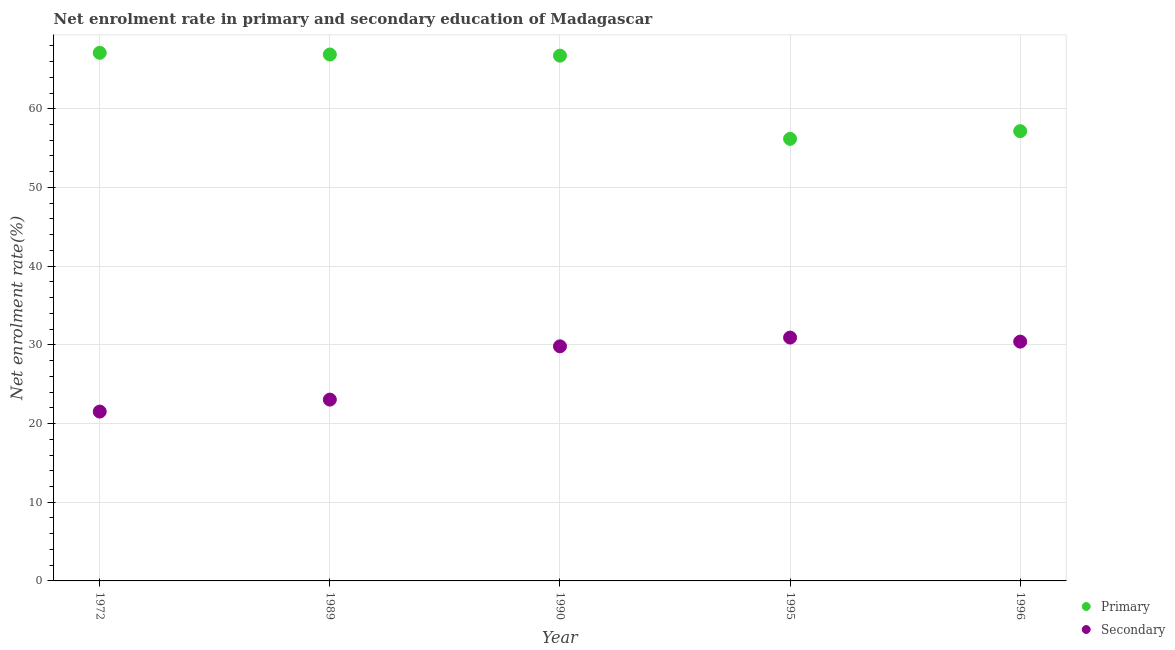What is the enrollment rate in primary education in 1989?
Your answer should be very brief. 66.9. Across all years, what is the maximum enrollment rate in secondary education?
Keep it short and to the point. 30.93. Across all years, what is the minimum enrollment rate in secondary education?
Ensure brevity in your answer.  21.52. In which year was the enrollment rate in secondary education maximum?
Your response must be concise. 1995. In which year was the enrollment rate in secondary education minimum?
Provide a succinct answer. 1972. What is the total enrollment rate in secondary education in the graph?
Keep it short and to the point. 135.71. What is the difference between the enrollment rate in secondary education in 1972 and that in 1996?
Provide a succinct answer. -8.89. What is the difference between the enrollment rate in primary education in 1989 and the enrollment rate in secondary education in 1996?
Provide a short and direct response. 36.49. What is the average enrollment rate in secondary education per year?
Ensure brevity in your answer.  27.14. In the year 1972, what is the difference between the enrollment rate in primary education and enrollment rate in secondary education?
Your answer should be very brief. 45.59. What is the ratio of the enrollment rate in primary education in 1972 to that in 1990?
Your answer should be compact. 1.01. Is the enrollment rate in secondary education in 1972 less than that in 1990?
Your response must be concise. Yes. What is the difference between the highest and the second highest enrollment rate in primary education?
Offer a terse response. 0.21. What is the difference between the highest and the lowest enrollment rate in secondary education?
Your answer should be compact. 9.41. In how many years, is the enrollment rate in primary education greater than the average enrollment rate in primary education taken over all years?
Provide a short and direct response. 3. Is the enrollment rate in secondary education strictly greater than the enrollment rate in primary education over the years?
Offer a terse response. No. How many dotlines are there?
Offer a terse response. 2. What is the difference between two consecutive major ticks on the Y-axis?
Provide a succinct answer. 10. Where does the legend appear in the graph?
Your response must be concise. Bottom right. How many legend labels are there?
Offer a terse response. 2. How are the legend labels stacked?
Make the answer very short. Vertical. What is the title of the graph?
Give a very brief answer. Net enrolment rate in primary and secondary education of Madagascar. What is the label or title of the X-axis?
Offer a terse response. Year. What is the label or title of the Y-axis?
Offer a terse response. Net enrolment rate(%). What is the Net enrolment rate(%) in Primary in 1972?
Keep it short and to the point. 67.11. What is the Net enrolment rate(%) of Secondary in 1972?
Give a very brief answer. 21.52. What is the Net enrolment rate(%) in Primary in 1989?
Ensure brevity in your answer.  66.9. What is the Net enrolment rate(%) of Secondary in 1989?
Your response must be concise. 23.04. What is the Net enrolment rate(%) in Primary in 1990?
Ensure brevity in your answer.  66.75. What is the Net enrolment rate(%) of Secondary in 1990?
Offer a very short reply. 29.81. What is the Net enrolment rate(%) in Primary in 1995?
Provide a succinct answer. 56.18. What is the Net enrolment rate(%) in Secondary in 1995?
Your answer should be very brief. 30.93. What is the Net enrolment rate(%) in Primary in 1996?
Make the answer very short. 57.16. What is the Net enrolment rate(%) of Secondary in 1996?
Provide a succinct answer. 30.41. Across all years, what is the maximum Net enrolment rate(%) in Primary?
Ensure brevity in your answer.  67.11. Across all years, what is the maximum Net enrolment rate(%) in Secondary?
Ensure brevity in your answer.  30.93. Across all years, what is the minimum Net enrolment rate(%) in Primary?
Offer a very short reply. 56.18. Across all years, what is the minimum Net enrolment rate(%) in Secondary?
Make the answer very short. 21.52. What is the total Net enrolment rate(%) in Primary in the graph?
Make the answer very short. 314.1. What is the total Net enrolment rate(%) in Secondary in the graph?
Offer a terse response. 135.71. What is the difference between the Net enrolment rate(%) in Primary in 1972 and that in 1989?
Your response must be concise. 0.21. What is the difference between the Net enrolment rate(%) of Secondary in 1972 and that in 1989?
Your answer should be very brief. -1.52. What is the difference between the Net enrolment rate(%) of Primary in 1972 and that in 1990?
Ensure brevity in your answer.  0.36. What is the difference between the Net enrolment rate(%) of Secondary in 1972 and that in 1990?
Ensure brevity in your answer.  -8.29. What is the difference between the Net enrolment rate(%) in Primary in 1972 and that in 1995?
Offer a very short reply. 10.93. What is the difference between the Net enrolment rate(%) in Secondary in 1972 and that in 1995?
Your answer should be compact. -9.41. What is the difference between the Net enrolment rate(%) in Primary in 1972 and that in 1996?
Your answer should be compact. 9.95. What is the difference between the Net enrolment rate(%) of Secondary in 1972 and that in 1996?
Provide a succinct answer. -8.89. What is the difference between the Net enrolment rate(%) in Primary in 1989 and that in 1990?
Give a very brief answer. 0.15. What is the difference between the Net enrolment rate(%) in Secondary in 1989 and that in 1990?
Provide a short and direct response. -6.77. What is the difference between the Net enrolment rate(%) of Primary in 1989 and that in 1995?
Your answer should be compact. 10.72. What is the difference between the Net enrolment rate(%) in Secondary in 1989 and that in 1995?
Your answer should be very brief. -7.88. What is the difference between the Net enrolment rate(%) of Primary in 1989 and that in 1996?
Provide a short and direct response. 9.74. What is the difference between the Net enrolment rate(%) of Secondary in 1989 and that in 1996?
Ensure brevity in your answer.  -7.37. What is the difference between the Net enrolment rate(%) of Primary in 1990 and that in 1995?
Offer a terse response. 10.57. What is the difference between the Net enrolment rate(%) in Secondary in 1990 and that in 1995?
Give a very brief answer. -1.11. What is the difference between the Net enrolment rate(%) in Primary in 1990 and that in 1996?
Your response must be concise. 9.59. What is the difference between the Net enrolment rate(%) of Secondary in 1990 and that in 1996?
Make the answer very short. -0.6. What is the difference between the Net enrolment rate(%) in Primary in 1995 and that in 1996?
Provide a short and direct response. -0.98. What is the difference between the Net enrolment rate(%) of Secondary in 1995 and that in 1996?
Give a very brief answer. 0.52. What is the difference between the Net enrolment rate(%) in Primary in 1972 and the Net enrolment rate(%) in Secondary in 1989?
Offer a very short reply. 44.07. What is the difference between the Net enrolment rate(%) in Primary in 1972 and the Net enrolment rate(%) in Secondary in 1990?
Ensure brevity in your answer.  37.3. What is the difference between the Net enrolment rate(%) in Primary in 1972 and the Net enrolment rate(%) in Secondary in 1995?
Your answer should be compact. 36.19. What is the difference between the Net enrolment rate(%) of Primary in 1972 and the Net enrolment rate(%) of Secondary in 1996?
Your answer should be compact. 36.7. What is the difference between the Net enrolment rate(%) in Primary in 1989 and the Net enrolment rate(%) in Secondary in 1990?
Provide a succinct answer. 37.09. What is the difference between the Net enrolment rate(%) in Primary in 1989 and the Net enrolment rate(%) in Secondary in 1995?
Provide a succinct answer. 35.97. What is the difference between the Net enrolment rate(%) in Primary in 1989 and the Net enrolment rate(%) in Secondary in 1996?
Make the answer very short. 36.49. What is the difference between the Net enrolment rate(%) in Primary in 1990 and the Net enrolment rate(%) in Secondary in 1995?
Offer a very short reply. 35.83. What is the difference between the Net enrolment rate(%) in Primary in 1990 and the Net enrolment rate(%) in Secondary in 1996?
Ensure brevity in your answer.  36.34. What is the difference between the Net enrolment rate(%) in Primary in 1995 and the Net enrolment rate(%) in Secondary in 1996?
Provide a succinct answer. 25.77. What is the average Net enrolment rate(%) in Primary per year?
Your answer should be compact. 62.82. What is the average Net enrolment rate(%) in Secondary per year?
Give a very brief answer. 27.14. In the year 1972, what is the difference between the Net enrolment rate(%) of Primary and Net enrolment rate(%) of Secondary?
Provide a succinct answer. 45.59. In the year 1989, what is the difference between the Net enrolment rate(%) in Primary and Net enrolment rate(%) in Secondary?
Your answer should be very brief. 43.86. In the year 1990, what is the difference between the Net enrolment rate(%) of Primary and Net enrolment rate(%) of Secondary?
Make the answer very short. 36.94. In the year 1995, what is the difference between the Net enrolment rate(%) of Primary and Net enrolment rate(%) of Secondary?
Your answer should be very brief. 25.25. In the year 1996, what is the difference between the Net enrolment rate(%) in Primary and Net enrolment rate(%) in Secondary?
Your answer should be compact. 26.75. What is the ratio of the Net enrolment rate(%) in Secondary in 1972 to that in 1989?
Keep it short and to the point. 0.93. What is the ratio of the Net enrolment rate(%) in Primary in 1972 to that in 1990?
Your answer should be compact. 1.01. What is the ratio of the Net enrolment rate(%) of Secondary in 1972 to that in 1990?
Your answer should be compact. 0.72. What is the ratio of the Net enrolment rate(%) in Primary in 1972 to that in 1995?
Give a very brief answer. 1.19. What is the ratio of the Net enrolment rate(%) of Secondary in 1972 to that in 1995?
Offer a terse response. 0.7. What is the ratio of the Net enrolment rate(%) in Primary in 1972 to that in 1996?
Provide a succinct answer. 1.17. What is the ratio of the Net enrolment rate(%) of Secondary in 1972 to that in 1996?
Offer a very short reply. 0.71. What is the ratio of the Net enrolment rate(%) of Secondary in 1989 to that in 1990?
Give a very brief answer. 0.77. What is the ratio of the Net enrolment rate(%) in Primary in 1989 to that in 1995?
Offer a terse response. 1.19. What is the ratio of the Net enrolment rate(%) in Secondary in 1989 to that in 1995?
Your response must be concise. 0.75. What is the ratio of the Net enrolment rate(%) of Primary in 1989 to that in 1996?
Offer a terse response. 1.17. What is the ratio of the Net enrolment rate(%) in Secondary in 1989 to that in 1996?
Ensure brevity in your answer.  0.76. What is the ratio of the Net enrolment rate(%) in Primary in 1990 to that in 1995?
Your response must be concise. 1.19. What is the ratio of the Net enrolment rate(%) in Secondary in 1990 to that in 1995?
Offer a terse response. 0.96. What is the ratio of the Net enrolment rate(%) of Primary in 1990 to that in 1996?
Keep it short and to the point. 1.17. What is the ratio of the Net enrolment rate(%) of Secondary in 1990 to that in 1996?
Provide a succinct answer. 0.98. What is the ratio of the Net enrolment rate(%) in Primary in 1995 to that in 1996?
Provide a succinct answer. 0.98. What is the difference between the highest and the second highest Net enrolment rate(%) in Primary?
Ensure brevity in your answer.  0.21. What is the difference between the highest and the second highest Net enrolment rate(%) in Secondary?
Your response must be concise. 0.52. What is the difference between the highest and the lowest Net enrolment rate(%) of Primary?
Provide a short and direct response. 10.93. What is the difference between the highest and the lowest Net enrolment rate(%) in Secondary?
Offer a terse response. 9.41. 